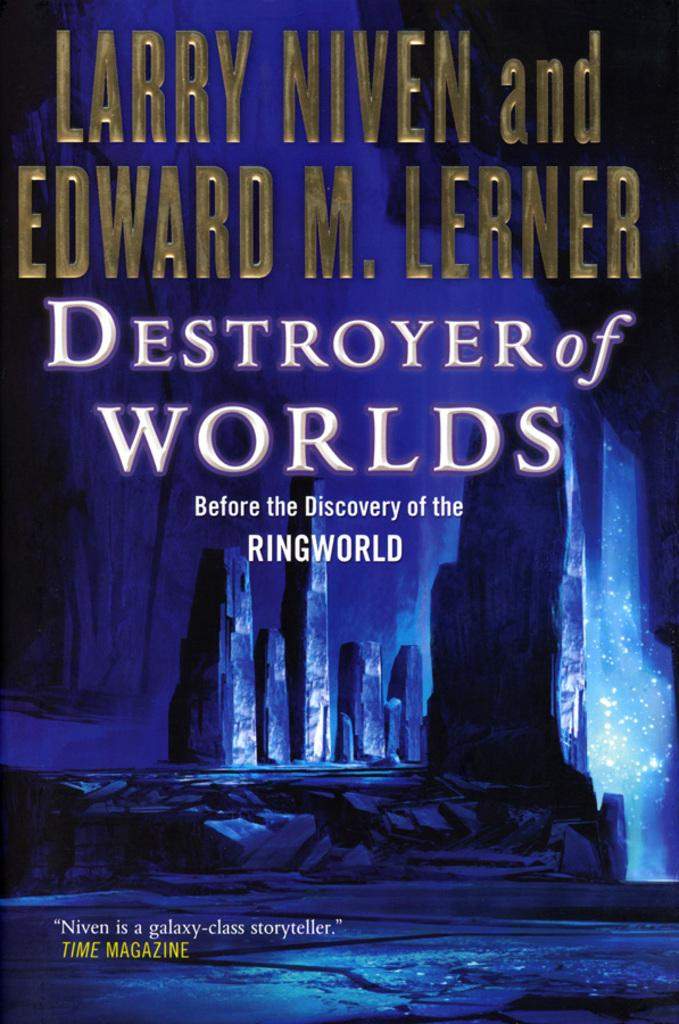Provide a one-sentence caption for the provided image. larry niven and edward m lerner's book destroyer of worlds. 